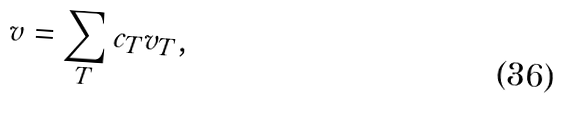<formula> <loc_0><loc_0><loc_500><loc_500>v = \sum _ { T } c _ { T } { v } _ { T } ,</formula> 